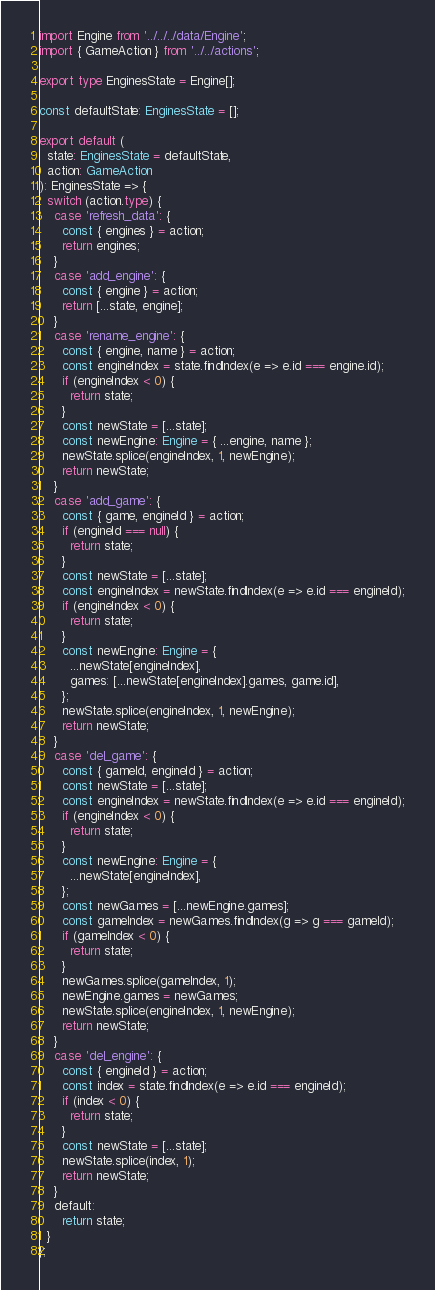Convert code to text. <code><loc_0><loc_0><loc_500><loc_500><_TypeScript_>import Engine from '../../../data/Engine';
import { GameAction } from '../../actions';

export type EnginesState = Engine[];

const defaultState: EnginesState = [];

export default (
  state: EnginesState = defaultState,
  action: GameAction
): EnginesState => {
  switch (action.type) {
    case 'refresh_data': {
      const { engines } = action;
      return engines;
    }
    case 'add_engine': {
      const { engine } = action;
      return [...state, engine];
    }
    case 'rename_engine': {
      const { engine, name } = action;
      const engineIndex = state.findIndex(e => e.id === engine.id);
      if (engineIndex < 0) {
        return state;
      }
      const newState = [...state];
      const newEngine: Engine = { ...engine, name };
      newState.splice(engineIndex, 1, newEngine);
      return newState;
    }
    case 'add_game': {
      const { game, engineId } = action;
      if (engineId === null) {
        return state;
      }
      const newState = [...state];
      const engineIndex = newState.findIndex(e => e.id === engineId);
      if (engineIndex < 0) {
        return state;
      }
      const newEngine: Engine = {
        ...newState[engineIndex],
        games: [...newState[engineIndex].games, game.id],
      };
      newState.splice(engineIndex, 1, newEngine);
      return newState;
    }
    case 'del_game': {
      const { gameId, engineId } = action;
      const newState = [...state];
      const engineIndex = newState.findIndex(e => e.id === engineId);
      if (engineIndex < 0) {
        return state;
      }
      const newEngine: Engine = {
        ...newState[engineIndex],
      };
      const newGames = [...newEngine.games];
      const gameIndex = newGames.findIndex(g => g === gameId);
      if (gameIndex < 0) {
        return state;
      }
      newGames.splice(gameIndex, 1);
      newEngine.games = newGames;
      newState.splice(engineIndex, 1, newEngine);
      return newState;
    }
    case 'del_engine': {
      const { engineId } = action;
      const index = state.findIndex(e => e.id === engineId);
      if (index < 0) {
        return state;
      }
      const newState = [...state];
      newState.splice(index, 1);
      return newState;
    }
    default:
      return state;
  }
};
</code> 